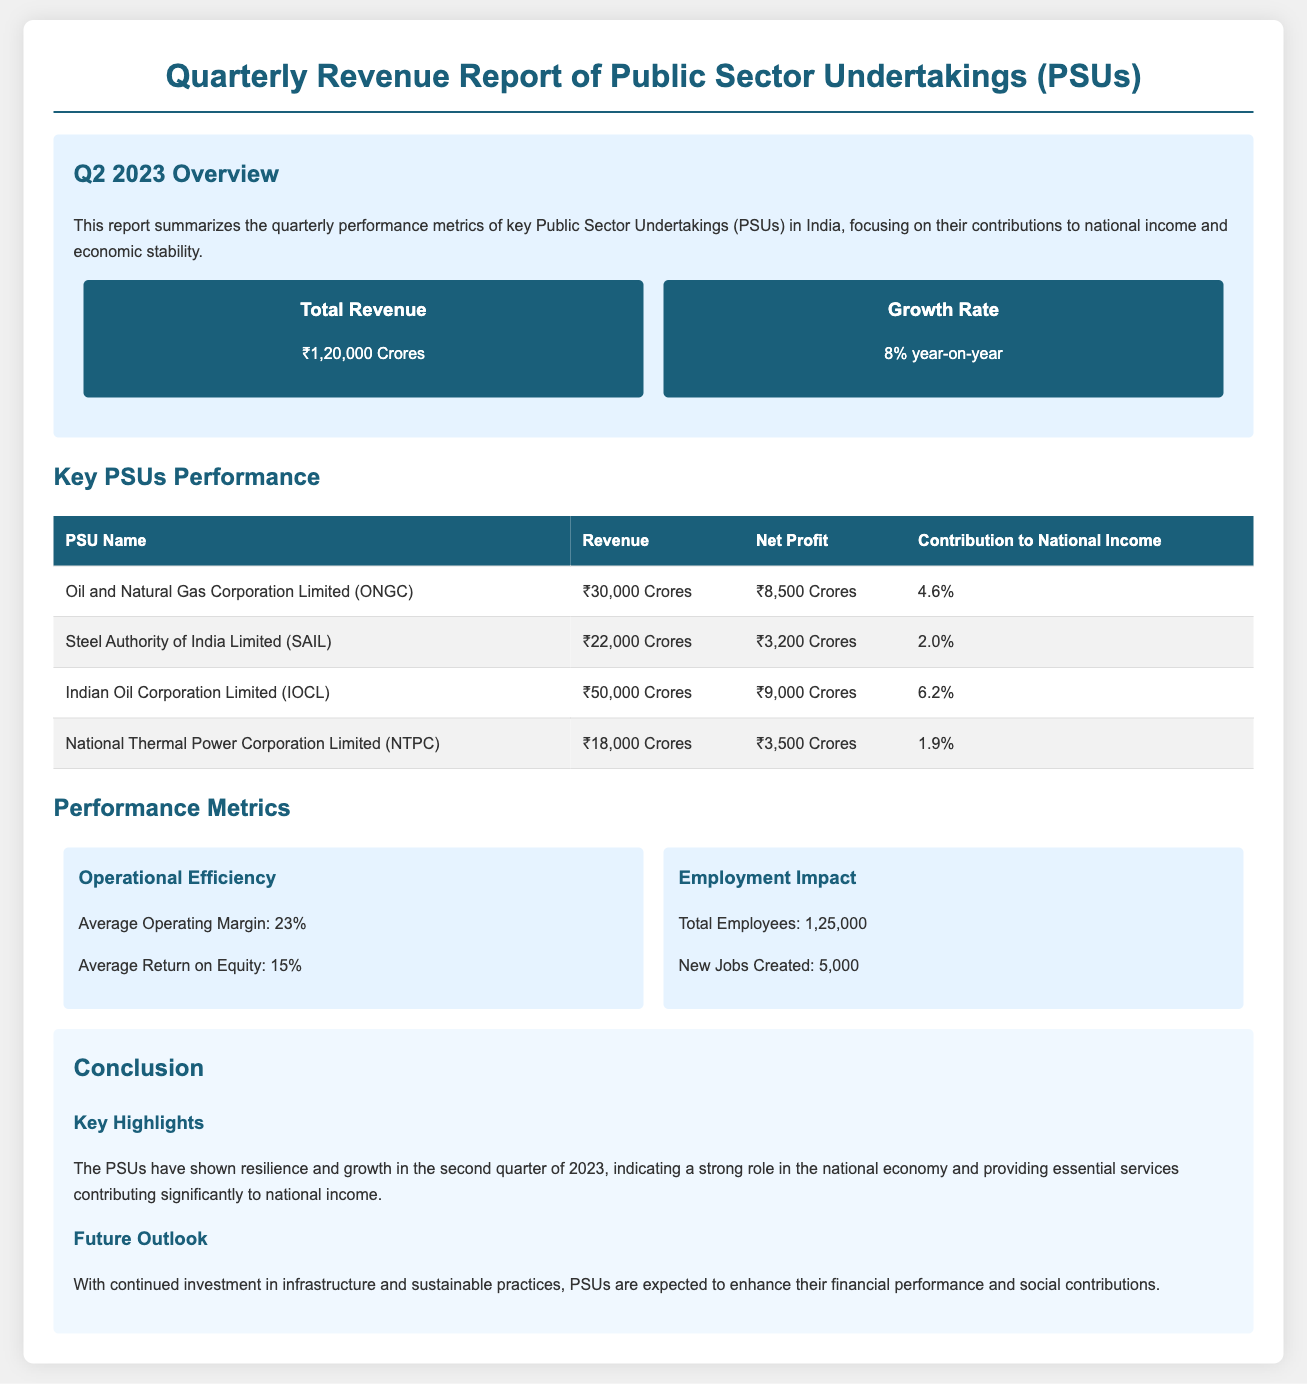What is the total revenue of PSUs? The total revenue is stated in the overview section of the document.
Answer: ₹1,20,000 Crores What was the growth rate compared to the previous year? The growth rate is mentioned in the key metrics section of the report.
Answer: 8% year-on-year Which PSU contributed the highest revenue? The revenue for each PSU is listed in the table, and the highest value determines the answer.
Answer: Indian Oil Corporation Limited (IOCL) What is the net profit of Oil and Natural Gas Corporation Limited (ONGC)? The net profit figure for ONGC can be found in the PSU performance table.
Answer: ₹8,500 Crores What is the average operating margin of PSUs? The operational efficiency section provides the average operating margin of PSUs.
Answer: 23% How many new jobs were created by PSUs in this quarter? The employment impact section lists the number of new jobs created.
Answer: 5,000 What percentage of national income did Steel Authority of India Limited (SAIL) contribute? The contribution to national income for SAIL is shown in the PSU table.
Answer: 2.0% What is the total number of employees across all PSUs mentioned? The employment impact section indicates the total number of employees.
Answer: 1,25,000 What was highlighted as a future outlook for PSUs? The future outlook section summarizes expectations for PSUs moving forward.
Answer: Enhance financial performance and social contributions 